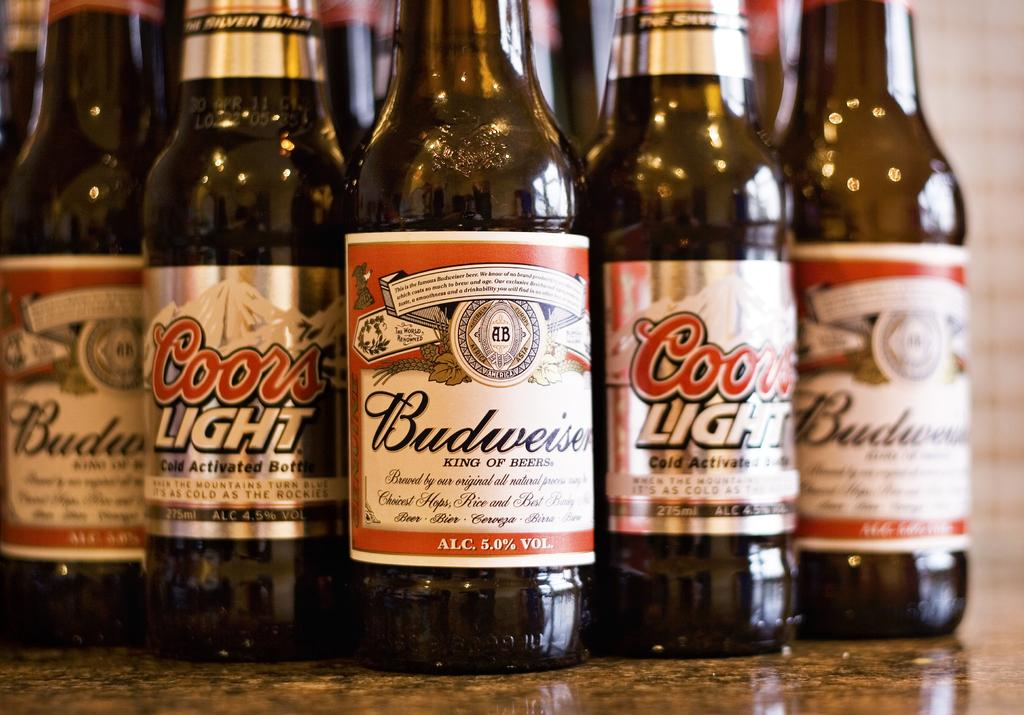<image>
Write a terse but informative summary of the picture. Many bottles of Budweiser together in a row. 